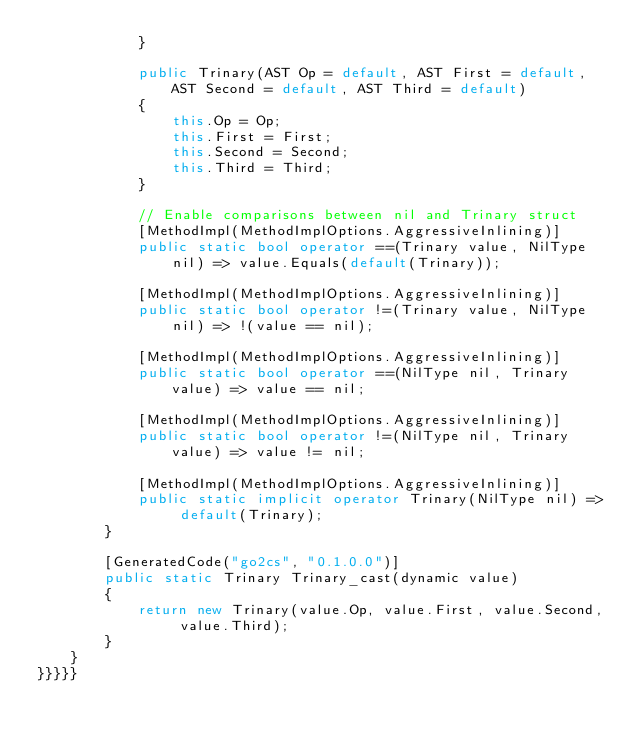Convert code to text. <code><loc_0><loc_0><loc_500><loc_500><_C#_>            }

            public Trinary(AST Op = default, AST First = default, AST Second = default, AST Third = default)
            {
                this.Op = Op;
                this.First = First;
                this.Second = Second;
                this.Third = Third;
            }

            // Enable comparisons between nil and Trinary struct
            [MethodImpl(MethodImplOptions.AggressiveInlining)]
            public static bool operator ==(Trinary value, NilType nil) => value.Equals(default(Trinary));

            [MethodImpl(MethodImplOptions.AggressiveInlining)]
            public static bool operator !=(Trinary value, NilType nil) => !(value == nil);

            [MethodImpl(MethodImplOptions.AggressiveInlining)]
            public static bool operator ==(NilType nil, Trinary value) => value == nil;

            [MethodImpl(MethodImplOptions.AggressiveInlining)]
            public static bool operator !=(NilType nil, Trinary value) => value != nil;

            [MethodImpl(MethodImplOptions.AggressiveInlining)]
            public static implicit operator Trinary(NilType nil) => default(Trinary);
        }

        [GeneratedCode("go2cs", "0.1.0.0")]
        public static Trinary Trinary_cast(dynamic value)
        {
            return new Trinary(value.Op, value.First, value.Second, value.Third);
        }
    }
}}}}}</code> 